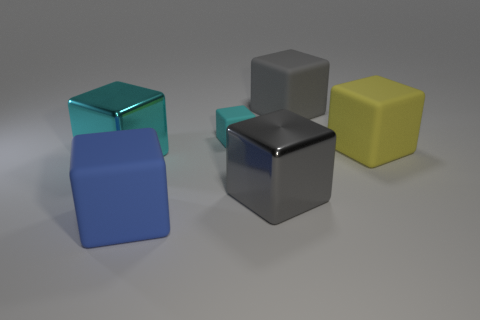Is the big yellow block behind the blue matte block made of the same material as the blue thing in front of the big cyan thing?
Offer a terse response. Yes. What is the color of the small rubber object?
Ensure brevity in your answer.  Cyan. How big is the object that is right of the big gray thing that is behind the gray block that is in front of the small cyan rubber thing?
Ensure brevity in your answer.  Large. How many other objects are there of the same size as the blue cube?
Provide a succinct answer. 4. What number of other cyan cubes are the same material as the tiny cyan cube?
Give a very brief answer. 0. There is a large rubber object in front of the gray metal thing; what is its shape?
Make the answer very short. Cube. Is the large cyan object made of the same material as the tiny cyan thing that is left of the yellow object?
Your answer should be compact. No. Are any big green objects visible?
Your response must be concise. No. There is a gray thing behind the large gray thing on the left side of the gray matte block; is there a large gray matte thing right of it?
Ensure brevity in your answer.  No. How many big objects are either red metallic cubes or blocks?
Provide a short and direct response. 5. 